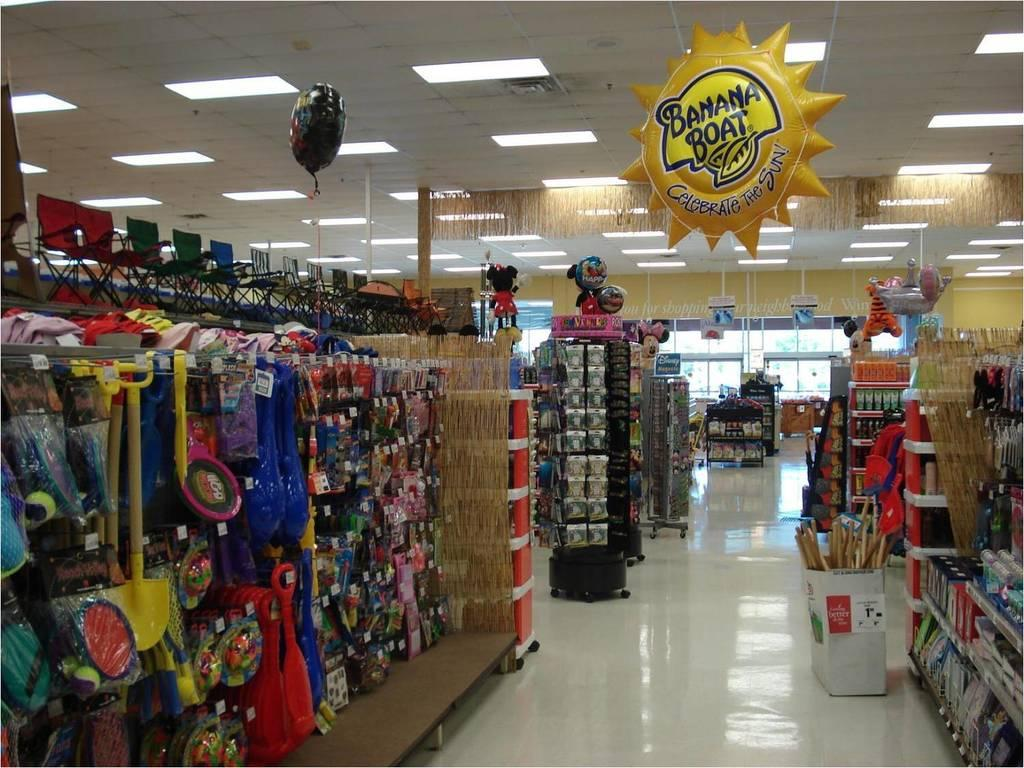<image>
Create a compact narrative representing the image presented. A store isle with a banana boat baloon hanging from the ceiling 